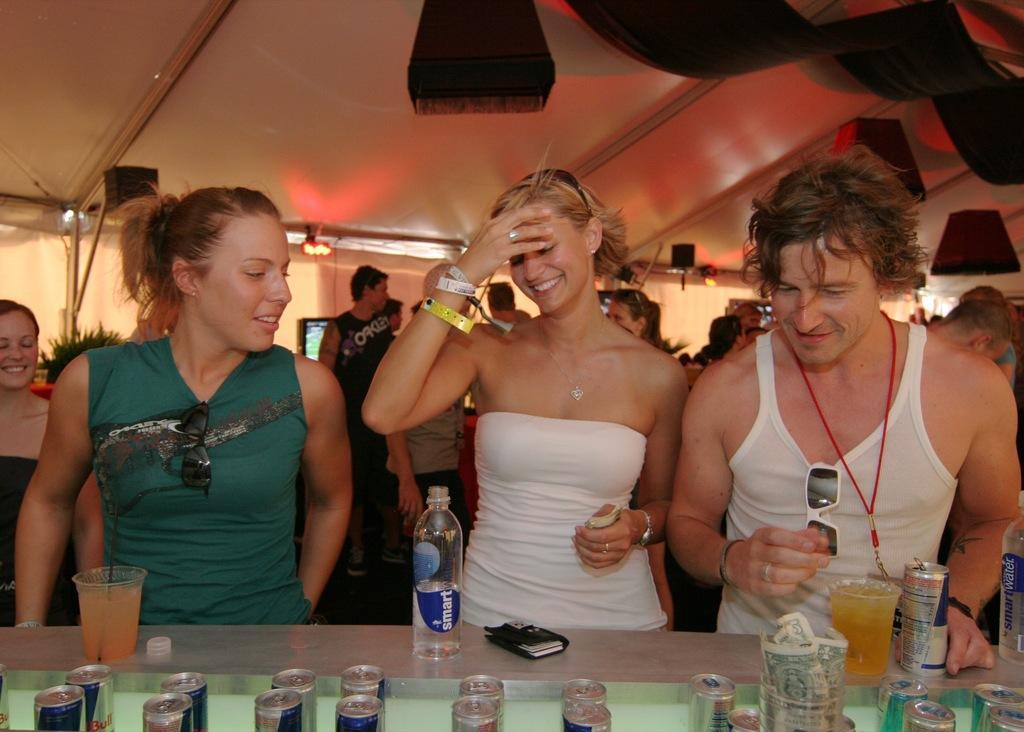Could you give a brief overview of what you see in this image? Here we can see people. This woman is smiling. On this table there are tins, glasses, currency, cap, bottles and object. This woman is holding a currency. Background we can see people, screen, plant and lights. This is a tent.  